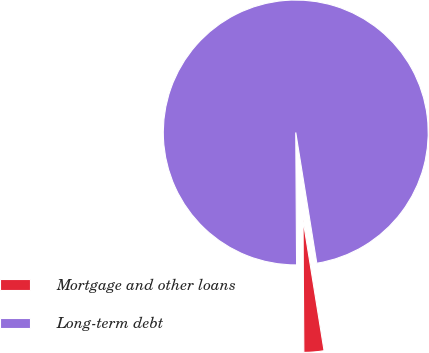<chart> <loc_0><loc_0><loc_500><loc_500><pie_chart><fcel>Mortgage and other loans<fcel>Long-term debt<nl><fcel>2.44%<fcel>97.56%<nl></chart> 